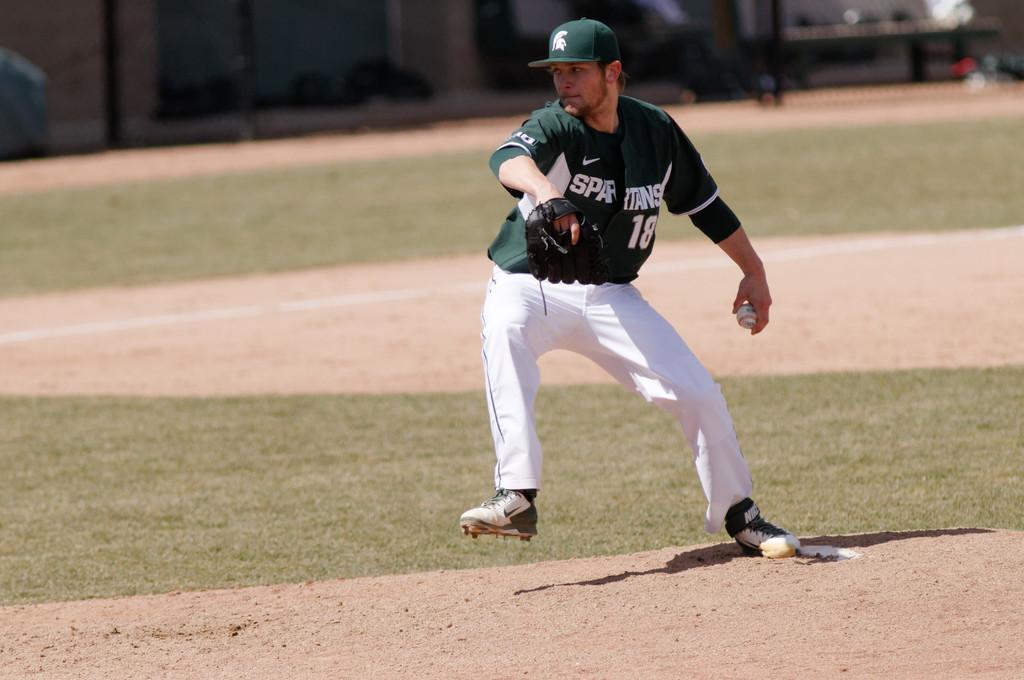What's the pitcher's number?
Offer a terse response. 18. What team is he playing for?
Offer a terse response. Spartans. 